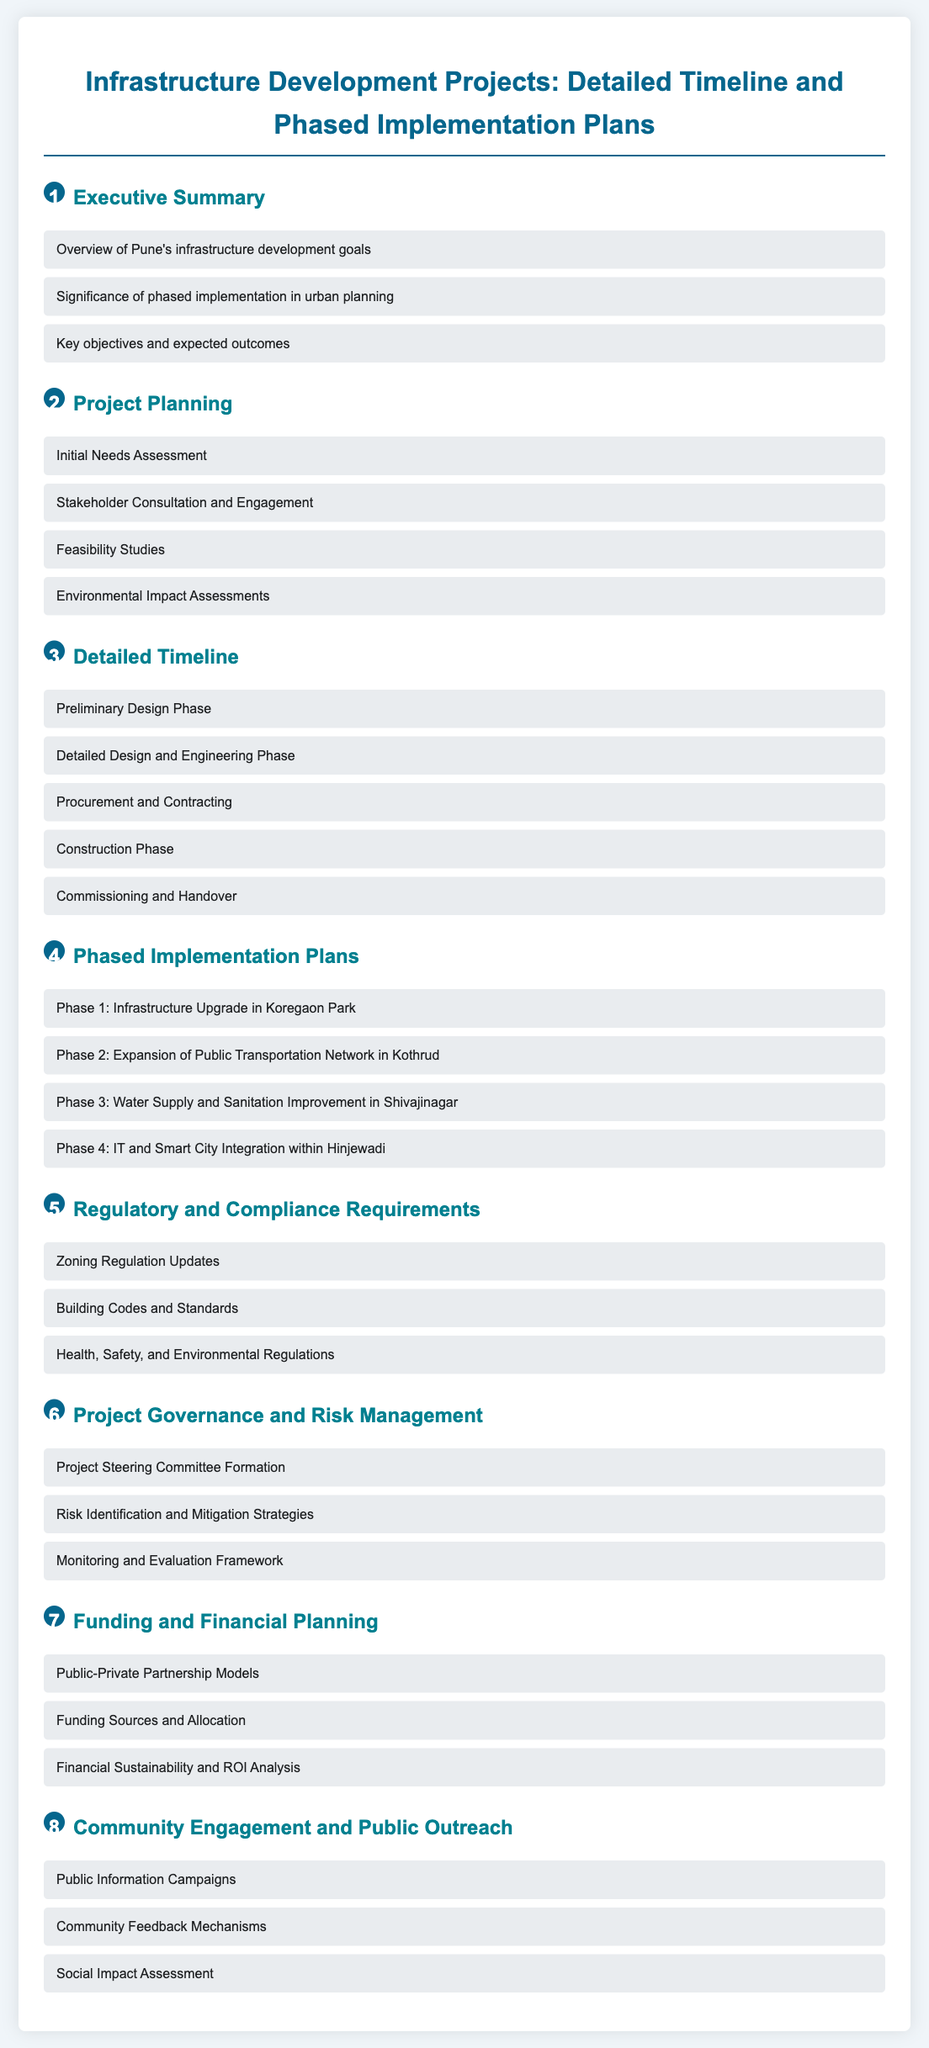What is the first phase of infrastructure development? The first phase listed in the phased implementation plans focuses on an infrastructure upgrade in Koregaon Park.
Answer: Infrastructure Upgrade in Koregaon Park How many phases are outlined in the document? The document presents a total of four phases for implementation.
Answer: Four phases What type of assessments are included in project planning? The project planning section lists feasibility studies as one of the key assessments.
Answer: Feasibility Studies Which area is designated for public transportation network expansion? The document specifies Kothrud as the target area for the expansion of the public transportation network.
Answer: Kothrud What is a key focus of the Community Engagement section? The Community Engagement section emphasizes social impact assessment as an important aspect of community involvement.
Answer: Social Impact Assessment What is the primary governance structure mentioned? The document indicates the formation of a project steering committee as the primary governance structure.
Answer: Project Steering Committee Formation What are the funding models referenced in the document? Public-private partnership models are mentioned as one of the funding models in the financial planning section.
Answer: Public-Private Partnership Models What regulation updates are highlighted in the document? The regulatory and compliance section highlights zoning regulation updates.
Answer: Zoning Regulation Updates 